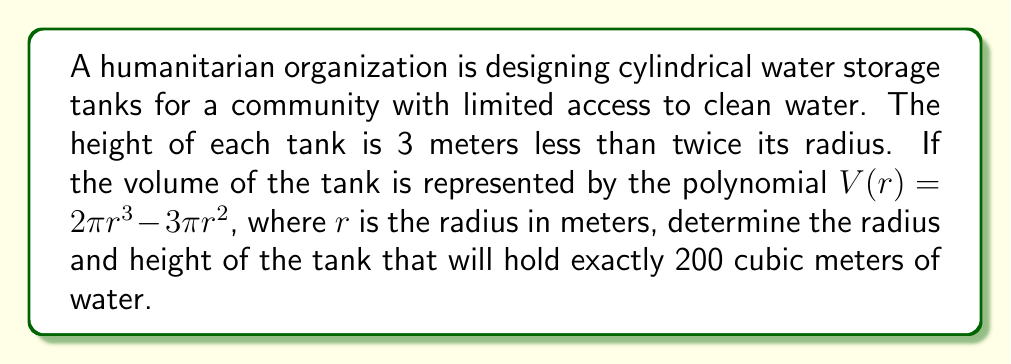Can you answer this question? Let's approach this problem step by step:

1) We're given that the volume of the tank is represented by:
   $$V(r) = 2\pi r^3 - 3\pi r^2$$

2) We need to find $r$ when $V(r) = 200$. So, let's set up the equation:
   $$200 = 2\pi r^3 - 3\pi r^2$$

3) Divide both sides by $\pi$:
   $$\frac{200}{\pi} = 2r^3 - 3r^2$$

4) Rearrange to standard form:
   $$2r^3 - 3r^2 - \frac{200}{\pi} = 0$$

5) This is a cubic equation. It's not easily solvable by factoring, so we'll need to use numerical methods or a graphing calculator to solve it.

6) Using a numerical solver, we find that $r \approx 3.973$ meters.

7) Now that we have the radius, we can find the height. We're told that the height is 3 meters less than twice the radius. So:
   $$h = 2r - 3 = 2(3.973) - 3 \approx 4.946$$ meters

8) We can verify our solution by calculating the volume:
   $$V = \pi r^2 h = \pi (3.973)^2 (4.946) \approx 200$$ cubic meters

Therefore, the tank should have a radius of approximately 3.973 meters and a height of approximately 4.946 meters.
Answer: Radius: $\approx 3.973$ meters
Height: $\approx 4.946$ meters 